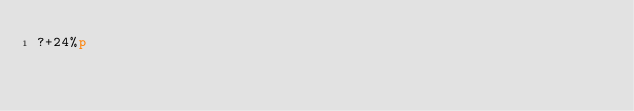Convert code to text. <code><loc_0><loc_0><loc_500><loc_500><_dc_>?+24%p</code> 